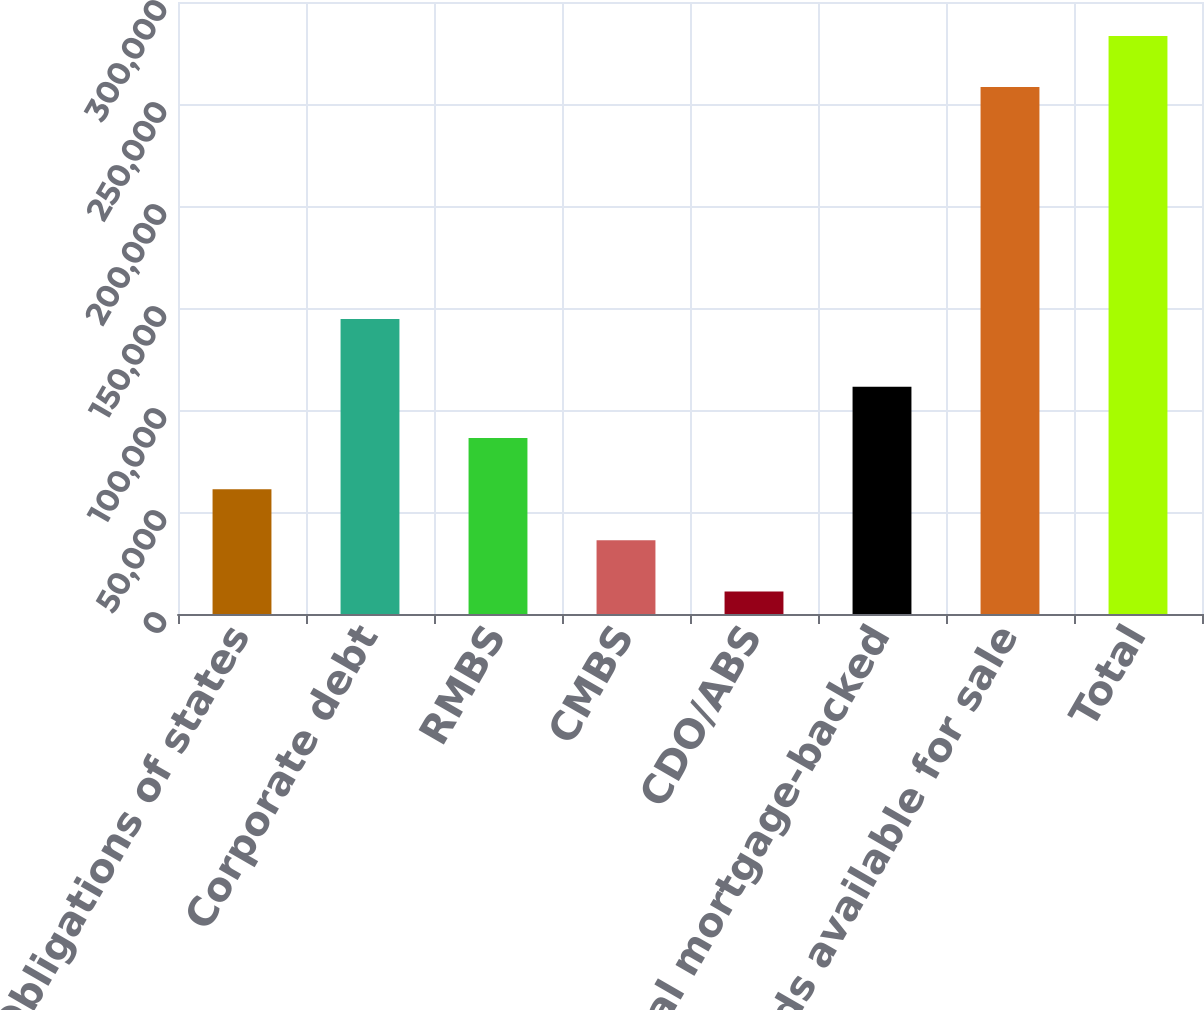Convert chart to OTSL. <chart><loc_0><loc_0><loc_500><loc_500><bar_chart><fcel>Obligations of states<fcel>Corporate debt<fcel>RMBS<fcel>CMBS<fcel>CDO/ABS<fcel>Total mortgage-backed<fcel>Total bonds available for sale<fcel>Total<nl><fcel>61192.4<fcel>144552<fcel>86284.6<fcel>36100.2<fcel>11008<fcel>111377<fcel>258274<fcel>283366<nl></chart> 